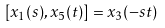Convert formula to latex. <formula><loc_0><loc_0><loc_500><loc_500>[ x _ { 1 } ( s ) , x _ { 5 } ( t ) ] = x _ { 3 } ( - s t )</formula> 